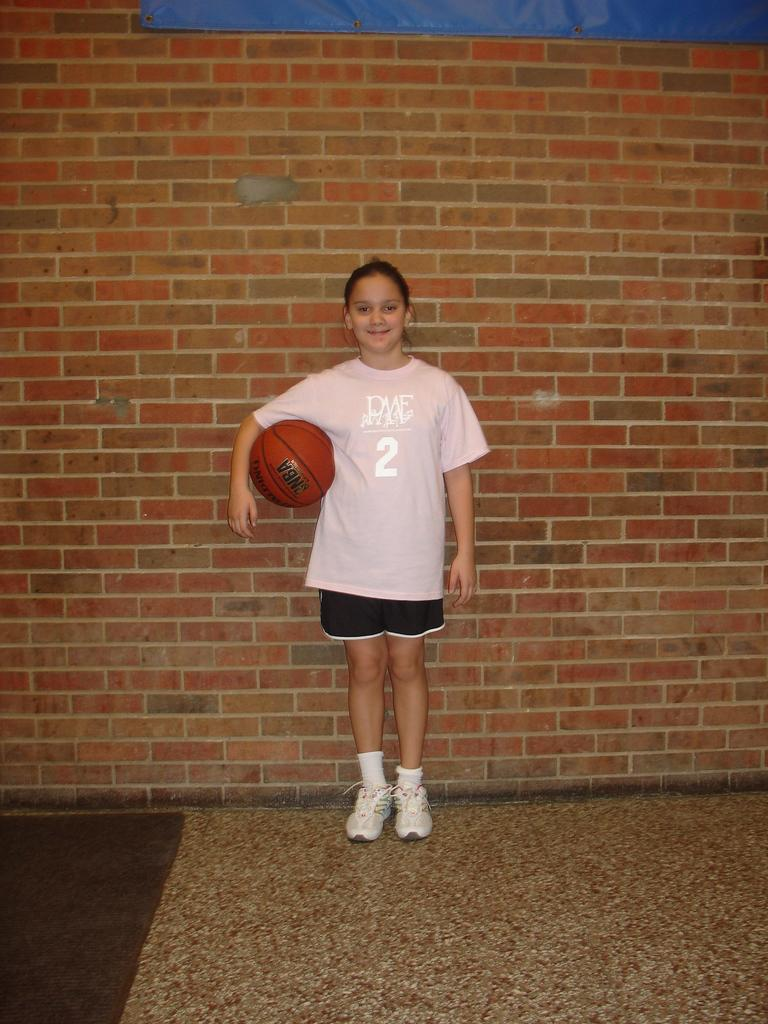Who is the main subject in the image? There is a girl in the image. What is the girl standing in front of? The girl is standing in front of a brick wall. What is the girl holding in the image? The girl is holding a ball. What type of reward does the girl receive from her mom for holding the ball? There is no mention of a mom or a reward in the image, and the girl is not holding the ball for any specific reason. 